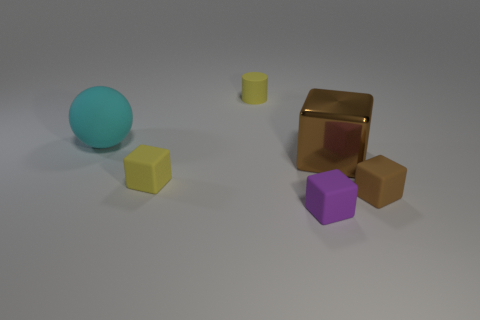There is a object that is both in front of the tiny yellow cylinder and behind the large brown cube; how big is it?
Your answer should be very brief. Large. Are there more blocks left of the brown shiny object than small purple matte blocks?
Offer a very short reply. Yes. What number of cubes are brown shiny things or big matte objects?
Provide a succinct answer. 1. The small rubber thing that is both right of the yellow cube and on the left side of the tiny purple rubber object has what shape?
Offer a terse response. Cylinder. Is the number of brown cubes that are behind the large cyan ball the same as the number of tiny objects in front of the large brown metal cube?
Provide a succinct answer. No. What number of objects are either red matte objects or big cyan objects?
Provide a short and direct response. 1. There is a matte cylinder that is the same size as the brown matte cube; what is its color?
Make the answer very short. Yellow. What number of objects are either large brown things that are in front of the cyan matte object or matte objects in front of the large sphere?
Your answer should be very brief. 4. Is the number of small brown objects that are on the left side of the tiny purple object the same as the number of large cyan spheres?
Provide a short and direct response. No. There is a yellow matte object that is behind the large ball; is it the same size as the brown object in front of the yellow matte block?
Provide a succinct answer. Yes. 